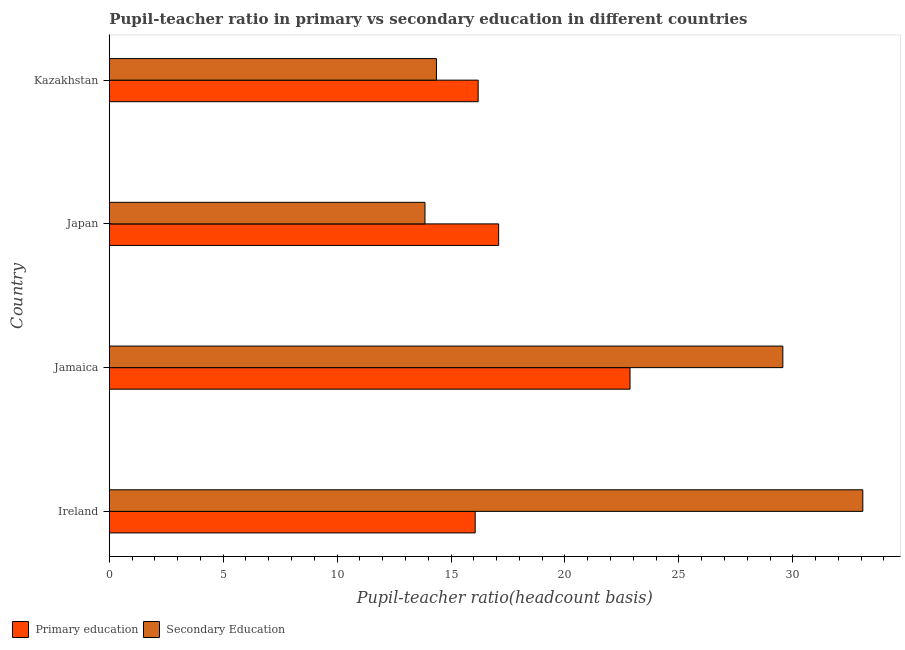How many different coloured bars are there?
Keep it short and to the point. 2. How many groups of bars are there?
Provide a succinct answer. 4. What is the label of the 3rd group of bars from the top?
Provide a succinct answer. Jamaica. What is the pupil-teacher ratio in primary education in Jamaica?
Make the answer very short. 22.86. Across all countries, what is the maximum pupil teacher ratio on secondary education?
Provide a succinct answer. 33.07. Across all countries, what is the minimum pupil teacher ratio on secondary education?
Make the answer very short. 13.86. In which country was the pupil teacher ratio on secondary education maximum?
Make the answer very short. Ireland. In which country was the pupil teacher ratio on secondary education minimum?
Your answer should be compact. Japan. What is the total pupil teacher ratio on secondary education in the graph?
Provide a succinct answer. 90.86. What is the difference between the pupil teacher ratio on secondary education in Jamaica and that in Japan?
Offer a terse response. 15.71. What is the difference between the pupil teacher ratio on secondary education in Jamaica and the pupil-teacher ratio in primary education in Ireland?
Make the answer very short. 13.5. What is the average pupil teacher ratio on secondary education per country?
Your answer should be very brief. 22.71. What is the difference between the pupil teacher ratio on secondary education and pupil-teacher ratio in primary education in Japan?
Your response must be concise. -3.23. In how many countries, is the pupil teacher ratio on secondary education greater than 28 ?
Your answer should be compact. 2. What is the ratio of the pupil-teacher ratio in primary education in Japan to that in Kazakhstan?
Provide a short and direct response. 1.06. What is the difference between the highest and the second highest pupil teacher ratio on secondary education?
Your answer should be compact. 3.51. What is the difference between the highest and the lowest pupil-teacher ratio in primary education?
Offer a terse response. 6.8. What does the 1st bar from the top in Japan represents?
Make the answer very short. Secondary Education. How many bars are there?
Offer a very short reply. 8. How many countries are there in the graph?
Ensure brevity in your answer.  4. Does the graph contain any zero values?
Give a very brief answer. No. Does the graph contain grids?
Provide a short and direct response. No. Where does the legend appear in the graph?
Provide a succinct answer. Bottom left. How many legend labels are there?
Keep it short and to the point. 2. How are the legend labels stacked?
Your response must be concise. Horizontal. What is the title of the graph?
Offer a terse response. Pupil-teacher ratio in primary vs secondary education in different countries. Does "Broad money growth" appear as one of the legend labels in the graph?
Your response must be concise. No. What is the label or title of the X-axis?
Ensure brevity in your answer.  Pupil-teacher ratio(headcount basis). What is the Pupil-teacher ratio(headcount basis) of Primary education in Ireland?
Provide a short and direct response. 16.06. What is the Pupil-teacher ratio(headcount basis) in Secondary Education in Ireland?
Your answer should be compact. 33.07. What is the Pupil-teacher ratio(headcount basis) of Primary education in Jamaica?
Your answer should be very brief. 22.86. What is the Pupil-teacher ratio(headcount basis) of Secondary Education in Jamaica?
Offer a terse response. 29.56. What is the Pupil-teacher ratio(headcount basis) of Primary education in Japan?
Your answer should be compact. 17.09. What is the Pupil-teacher ratio(headcount basis) of Secondary Education in Japan?
Offer a very short reply. 13.86. What is the Pupil-teacher ratio(headcount basis) of Primary education in Kazakhstan?
Offer a terse response. 16.19. What is the Pupil-teacher ratio(headcount basis) of Secondary Education in Kazakhstan?
Your answer should be compact. 14.36. Across all countries, what is the maximum Pupil-teacher ratio(headcount basis) of Primary education?
Offer a very short reply. 22.86. Across all countries, what is the maximum Pupil-teacher ratio(headcount basis) in Secondary Education?
Ensure brevity in your answer.  33.07. Across all countries, what is the minimum Pupil-teacher ratio(headcount basis) in Primary education?
Keep it short and to the point. 16.06. Across all countries, what is the minimum Pupil-teacher ratio(headcount basis) of Secondary Education?
Keep it short and to the point. 13.86. What is the total Pupil-teacher ratio(headcount basis) of Primary education in the graph?
Make the answer very short. 72.2. What is the total Pupil-teacher ratio(headcount basis) of Secondary Education in the graph?
Provide a succinct answer. 90.86. What is the difference between the Pupil-teacher ratio(headcount basis) of Primary education in Ireland and that in Jamaica?
Ensure brevity in your answer.  -6.8. What is the difference between the Pupil-teacher ratio(headcount basis) of Secondary Education in Ireland and that in Jamaica?
Offer a very short reply. 3.51. What is the difference between the Pupil-teacher ratio(headcount basis) of Primary education in Ireland and that in Japan?
Your answer should be very brief. -1.03. What is the difference between the Pupil-teacher ratio(headcount basis) in Secondary Education in Ireland and that in Japan?
Ensure brevity in your answer.  19.22. What is the difference between the Pupil-teacher ratio(headcount basis) of Primary education in Ireland and that in Kazakhstan?
Provide a short and direct response. -0.13. What is the difference between the Pupil-teacher ratio(headcount basis) in Secondary Education in Ireland and that in Kazakhstan?
Offer a very short reply. 18.71. What is the difference between the Pupil-teacher ratio(headcount basis) of Primary education in Jamaica and that in Japan?
Keep it short and to the point. 5.77. What is the difference between the Pupil-teacher ratio(headcount basis) in Secondary Education in Jamaica and that in Japan?
Offer a very short reply. 15.71. What is the difference between the Pupil-teacher ratio(headcount basis) of Primary education in Jamaica and that in Kazakhstan?
Offer a very short reply. 6.67. What is the difference between the Pupil-teacher ratio(headcount basis) of Secondary Education in Jamaica and that in Kazakhstan?
Offer a terse response. 15.2. What is the difference between the Pupil-teacher ratio(headcount basis) of Primary education in Japan and that in Kazakhstan?
Ensure brevity in your answer.  0.9. What is the difference between the Pupil-teacher ratio(headcount basis) in Secondary Education in Japan and that in Kazakhstan?
Your answer should be compact. -0.5. What is the difference between the Pupil-teacher ratio(headcount basis) of Primary education in Ireland and the Pupil-teacher ratio(headcount basis) of Secondary Education in Jamaica?
Offer a terse response. -13.5. What is the difference between the Pupil-teacher ratio(headcount basis) in Primary education in Ireland and the Pupil-teacher ratio(headcount basis) in Secondary Education in Japan?
Ensure brevity in your answer.  2.2. What is the difference between the Pupil-teacher ratio(headcount basis) of Primary education in Jamaica and the Pupil-teacher ratio(headcount basis) of Secondary Education in Japan?
Offer a very short reply. 9. What is the difference between the Pupil-teacher ratio(headcount basis) in Primary education in Jamaica and the Pupil-teacher ratio(headcount basis) in Secondary Education in Kazakhstan?
Your response must be concise. 8.5. What is the difference between the Pupil-teacher ratio(headcount basis) in Primary education in Japan and the Pupil-teacher ratio(headcount basis) in Secondary Education in Kazakhstan?
Offer a terse response. 2.73. What is the average Pupil-teacher ratio(headcount basis) in Primary education per country?
Ensure brevity in your answer.  18.05. What is the average Pupil-teacher ratio(headcount basis) in Secondary Education per country?
Give a very brief answer. 22.71. What is the difference between the Pupil-teacher ratio(headcount basis) of Primary education and Pupil-teacher ratio(headcount basis) of Secondary Education in Ireland?
Ensure brevity in your answer.  -17.01. What is the difference between the Pupil-teacher ratio(headcount basis) in Primary education and Pupil-teacher ratio(headcount basis) in Secondary Education in Jamaica?
Offer a terse response. -6.71. What is the difference between the Pupil-teacher ratio(headcount basis) in Primary education and Pupil-teacher ratio(headcount basis) in Secondary Education in Japan?
Your response must be concise. 3.23. What is the difference between the Pupil-teacher ratio(headcount basis) in Primary education and Pupil-teacher ratio(headcount basis) in Secondary Education in Kazakhstan?
Make the answer very short. 1.83. What is the ratio of the Pupil-teacher ratio(headcount basis) of Primary education in Ireland to that in Jamaica?
Ensure brevity in your answer.  0.7. What is the ratio of the Pupil-teacher ratio(headcount basis) of Secondary Education in Ireland to that in Jamaica?
Your answer should be very brief. 1.12. What is the ratio of the Pupil-teacher ratio(headcount basis) in Primary education in Ireland to that in Japan?
Make the answer very short. 0.94. What is the ratio of the Pupil-teacher ratio(headcount basis) in Secondary Education in Ireland to that in Japan?
Make the answer very short. 2.39. What is the ratio of the Pupil-teacher ratio(headcount basis) in Primary education in Ireland to that in Kazakhstan?
Offer a terse response. 0.99. What is the ratio of the Pupil-teacher ratio(headcount basis) of Secondary Education in Ireland to that in Kazakhstan?
Ensure brevity in your answer.  2.3. What is the ratio of the Pupil-teacher ratio(headcount basis) in Primary education in Jamaica to that in Japan?
Your response must be concise. 1.34. What is the ratio of the Pupil-teacher ratio(headcount basis) in Secondary Education in Jamaica to that in Japan?
Make the answer very short. 2.13. What is the ratio of the Pupil-teacher ratio(headcount basis) of Primary education in Jamaica to that in Kazakhstan?
Your answer should be compact. 1.41. What is the ratio of the Pupil-teacher ratio(headcount basis) of Secondary Education in Jamaica to that in Kazakhstan?
Give a very brief answer. 2.06. What is the ratio of the Pupil-teacher ratio(headcount basis) of Primary education in Japan to that in Kazakhstan?
Provide a succinct answer. 1.06. What is the ratio of the Pupil-teacher ratio(headcount basis) in Secondary Education in Japan to that in Kazakhstan?
Your response must be concise. 0.96. What is the difference between the highest and the second highest Pupil-teacher ratio(headcount basis) of Primary education?
Keep it short and to the point. 5.77. What is the difference between the highest and the second highest Pupil-teacher ratio(headcount basis) of Secondary Education?
Offer a very short reply. 3.51. What is the difference between the highest and the lowest Pupil-teacher ratio(headcount basis) in Primary education?
Give a very brief answer. 6.8. What is the difference between the highest and the lowest Pupil-teacher ratio(headcount basis) of Secondary Education?
Offer a very short reply. 19.22. 